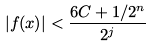<formula> <loc_0><loc_0><loc_500><loc_500>| f ( x ) | < \frac { 6 C + 1 / 2 ^ { n } } { 2 ^ { j } }</formula> 